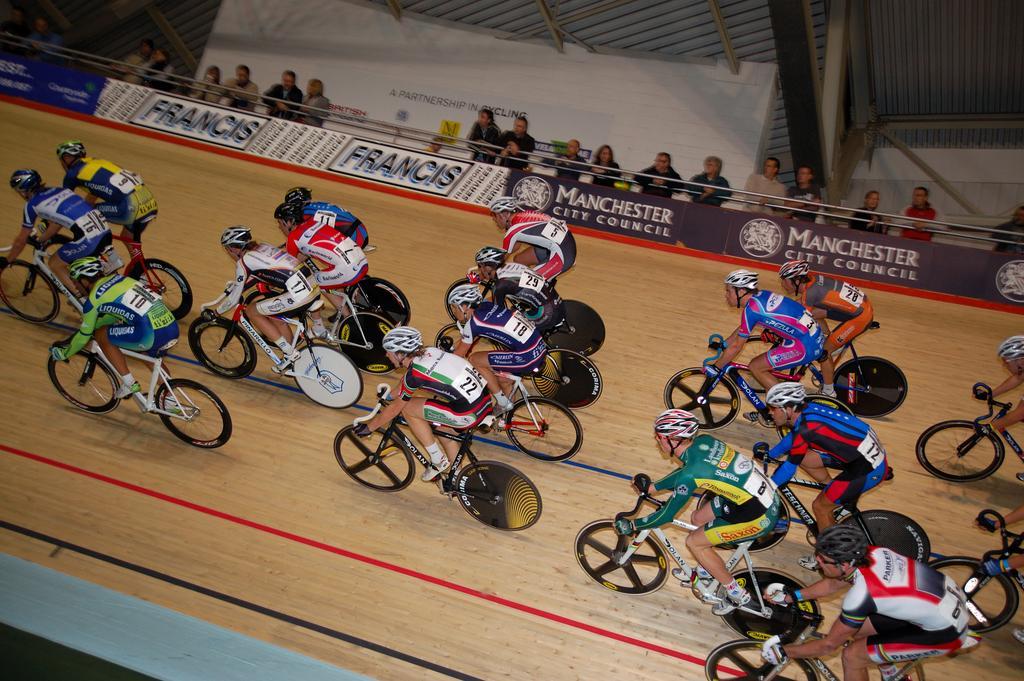Can you describe this image briefly? There are many people wearing helmets and gloves are riding cycles. In the back there are banners. Also there are many people standing. 